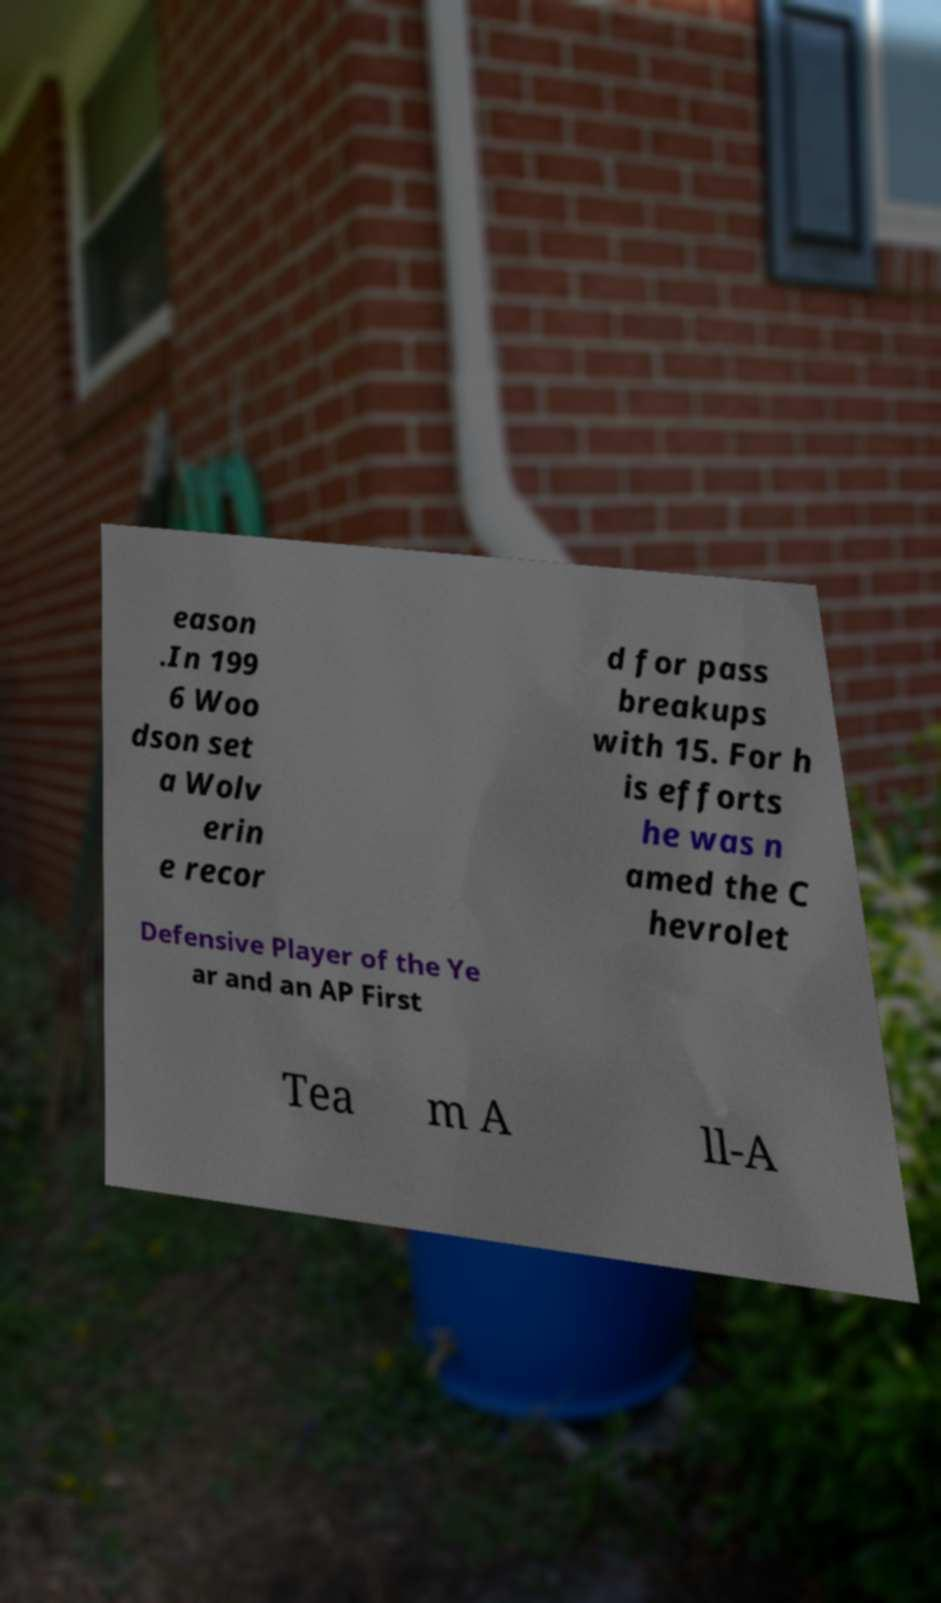What messages or text are displayed in this image? I need them in a readable, typed format. eason .In 199 6 Woo dson set a Wolv erin e recor d for pass breakups with 15. For h is efforts he was n amed the C hevrolet Defensive Player of the Ye ar and an AP First Tea m A ll-A 